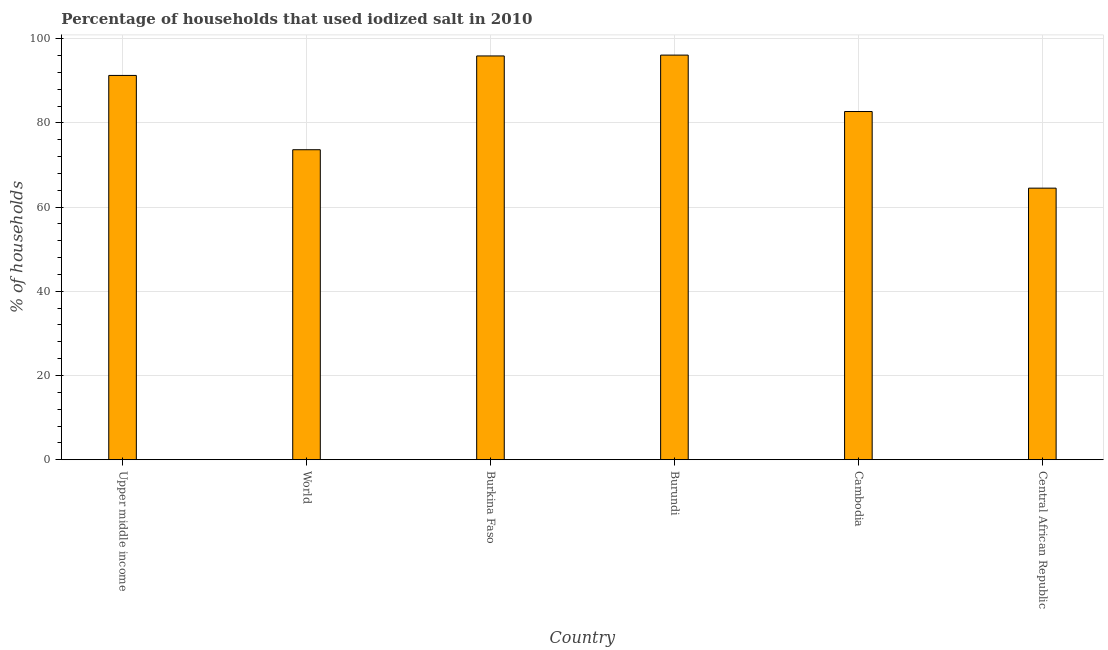Does the graph contain any zero values?
Provide a succinct answer. No. What is the title of the graph?
Provide a short and direct response. Percentage of households that used iodized salt in 2010. What is the label or title of the X-axis?
Provide a short and direct response. Country. What is the label or title of the Y-axis?
Provide a succinct answer. % of households. What is the percentage of households where iodized salt is consumed in Burkina Faso?
Provide a succinct answer. 95.9. Across all countries, what is the maximum percentage of households where iodized salt is consumed?
Provide a succinct answer. 96.1. Across all countries, what is the minimum percentage of households where iodized salt is consumed?
Offer a very short reply. 64.5. In which country was the percentage of households where iodized salt is consumed maximum?
Provide a short and direct response. Burundi. In which country was the percentage of households where iodized salt is consumed minimum?
Ensure brevity in your answer.  Central African Republic. What is the sum of the percentage of households where iodized salt is consumed?
Offer a very short reply. 504.1. What is the difference between the percentage of households where iodized salt is consumed in Central African Republic and World?
Your answer should be very brief. -9.12. What is the average percentage of households where iodized salt is consumed per country?
Your response must be concise. 84.02. What is the median percentage of households where iodized salt is consumed?
Your response must be concise. 86.99. What is the ratio of the percentage of households where iodized salt is consumed in Burundi to that in Upper middle income?
Your answer should be very brief. 1.05. Is the percentage of households where iodized salt is consumed in Burundi less than that in Central African Republic?
Provide a short and direct response. No. Is the sum of the percentage of households where iodized salt is consumed in Central African Republic and World greater than the maximum percentage of households where iodized salt is consumed across all countries?
Provide a short and direct response. Yes. What is the difference between the highest and the lowest percentage of households where iodized salt is consumed?
Provide a succinct answer. 31.6. In how many countries, is the percentage of households where iodized salt is consumed greater than the average percentage of households where iodized salt is consumed taken over all countries?
Ensure brevity in your answer.  3. How many bars are there?
Give a very brief answer. 6. How many countries are there in the graph?
Keep it short and to the point. 6. Are the values on the major ticks of Y-axis written in scientific E-notation?
Provide a short and direct response. No. What is the % of households in Upper middle income?
Offer a very short reply. 91.27. What is the % of households of World?
Keep it short and to the point. 73.62. What is the % of households of Burkina Faso?
Provide a succinct answer. 95.9. What is the % of households in Burundi?
Ensure brevity in your answer.  96.1. What is the % of households in Cambodia?
Your answer should be compact. 82.7. What is the % of households of Central African Republic?
Keep it short and to the point. 64.5. What is the difference between the % of households in Upper middle income and World?
Give a very brief answer. 17.65. What is the difference between the % of households in Upper middle income and Burkina Faso?
Make the answer very short. -4.63. What is the difference between the % of households in Upper middle income and Burundi?
Offer a very short reply. -4.83. What is the difference between the % of households in Upper middle income and Cambodia?
Provide a short and direct response. 8.57. What is the difference between the % of households in Upper middle income and Central African Republic?
Offer a very short reply. 26.77. What is the difference between the % of households in World and Burkina Faso?
Keep it short and to the point. -22.28. What is the difference between the % of households in World and Burundi?
Your response must be concise. -22.48. What is the difference between the % of households in World and Cambodia?
Your response must be concise. -9.08. What is the difference between the % of households in World and Central African Republic?
Ensure brevity in your answer.  9.12. What is the difference between the % of households in Burkina Faso and Central African Republic?
Provide a succinct answer. 31.4. What is the difference between the % of households in Burundi and Cambodia?
Make the answer very short. 13.4. What is the difference between the % of households in Burundi and Central African Republic?
Make the answer very short. 31.6. What is the difference between the % of households in Cambodia and Central African Republic?
Offer a very short reply. 18.2. What is the ratio of the % of households in Upper middle income to that in World?
Provide a succinct answer. 1.24. What is the ratio of the % of households in Upper middle income to that in Burkina Faso?
Your answer should be very brief. 0.95. What is the ratio of the % of households in Upper middle income to that in Burundi?
Ensure brevity in your answer.  0.95. What is the ratio of the % of households in Upper middle income to that in Cambodia?
Keep it short and to the point. 1.1. What is the ratio of the % of households in Upper middle income to that in Central African Republic?
Offer a very short reply. 1.42. What is the ratio of the % of households in World to that in Burkina Faso?
Your answer should be very brief. 0.77. What is the ratio of the % of households in World to that in Burundi?
Keep it short and to the point. 0.77. What is the ratio of the % of households in World to that in Cambodia?
Offer a terse response. 0.89. What is the ratio of the % of households in World to that in Central African Republic?
Keep it short and to the point. 1.14. What is the ratio of the % of households in Burkina Faso to that in Burundi?
Your response must be concise. 1. What is the ratio of the % of households in Burkina Faso to that in Cambodia?
Provide a succinct answer. 1.16. What is the ratio of the % of households in Burkina Faso to that in Central African Republic?
Your answer should be very brief. 1.49. What is the ratio of the % of households in Burundi to that in Cambodia?
Your answer should be very brief. 1.16. What is the ratio of the % of households in Burundi to that in Central African Republic?
Offer a terse response. 1.49. What is the ratio of the % of households in Cambodia to that in Central African Republic?
Give a very brief answer. 1.28. 